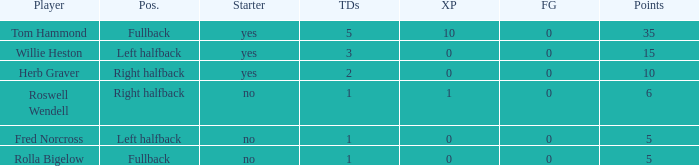Considering left halfback willie heston has over 15 points, what is the lowest amount of touchdowns he has accomplished? None. 